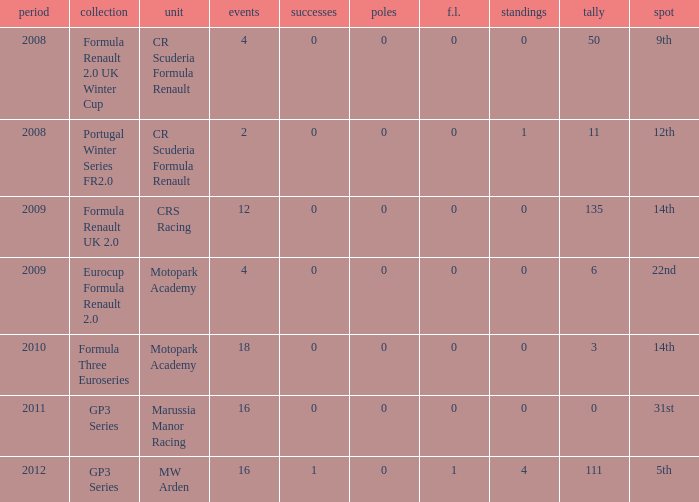How many points does Marussia Manor Racing have? 1.0. 